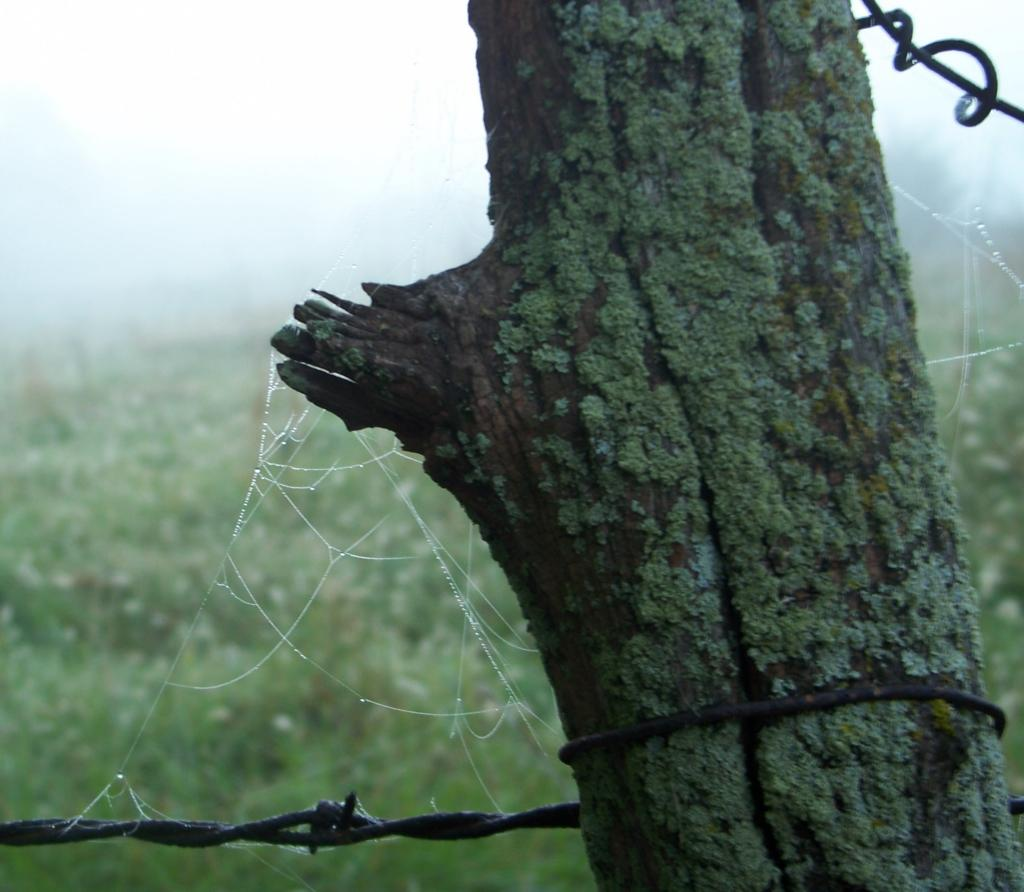What object is the main focus of the image? There is a trunk in the image. How would you describe the background of the image? The background of the image is blurred. What type of natural environment can be seen in the image? There is greenery visible in the background of the image. What else is visible in the background of the image? The sky is visible in the background of the image. What type of skirt is the cow wearing in the image? There is no cow or skirt present in the image. What is the limit of the image's resolution? The image's resolution is not mentioned in the provided facts, so it cannot be determined. 